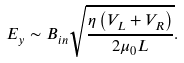<formula> <loc_0><loc_0><loc_500><loc_500>E _ { y } \sim B _ { i n } \sqrt { \frac { \eta \left ( V _ { L } + V _ { R } \right ) } { 2 \mu _ { 0 } L } } .</formula> 